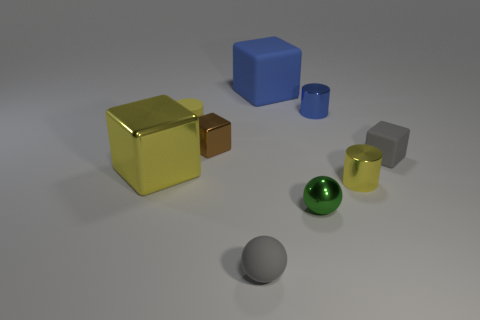What number of things are either yellow metallic cylinders or small cylinders that are in front of the large yellow object?
Your response must be concise. 1. Is there a small gray sphere that has the same material as the big blue block?
Provide a short and direct response. Yes. There is a brown block that is the same size as the green metallic sphere; what is its material?
Offer a terse response. Metal. What is the small yellow cylinder that is right of the gray matte object that is in front of the big metallic object made of?
Ensure brevity in your answer.  Metal. There is a blue object behind the blue cylinder; does it have the same shape as the brown thing?
Your answer should be very brief. Yes. The large thing that is made of the same material as the tiny blue object is what color?
Your answer should be compact. Yellow. There is a large thing that is in front of the gray cube; what material is it?
Offer a very short reply. Metal. There is a small green object; does it have the same shape as the small gray object that is left of the blue cylinder?
Ensure brevity in your answer.  Yes. There is a tiny cylinder that is both behind the yellow metal block and to the right of the small brown metallic block; what is it made of?
Keep it short and to the point. Metal. There is a matte block that is the same size as the rubber cylinder; what is its color?
Keep it short and to the point. Gray. 